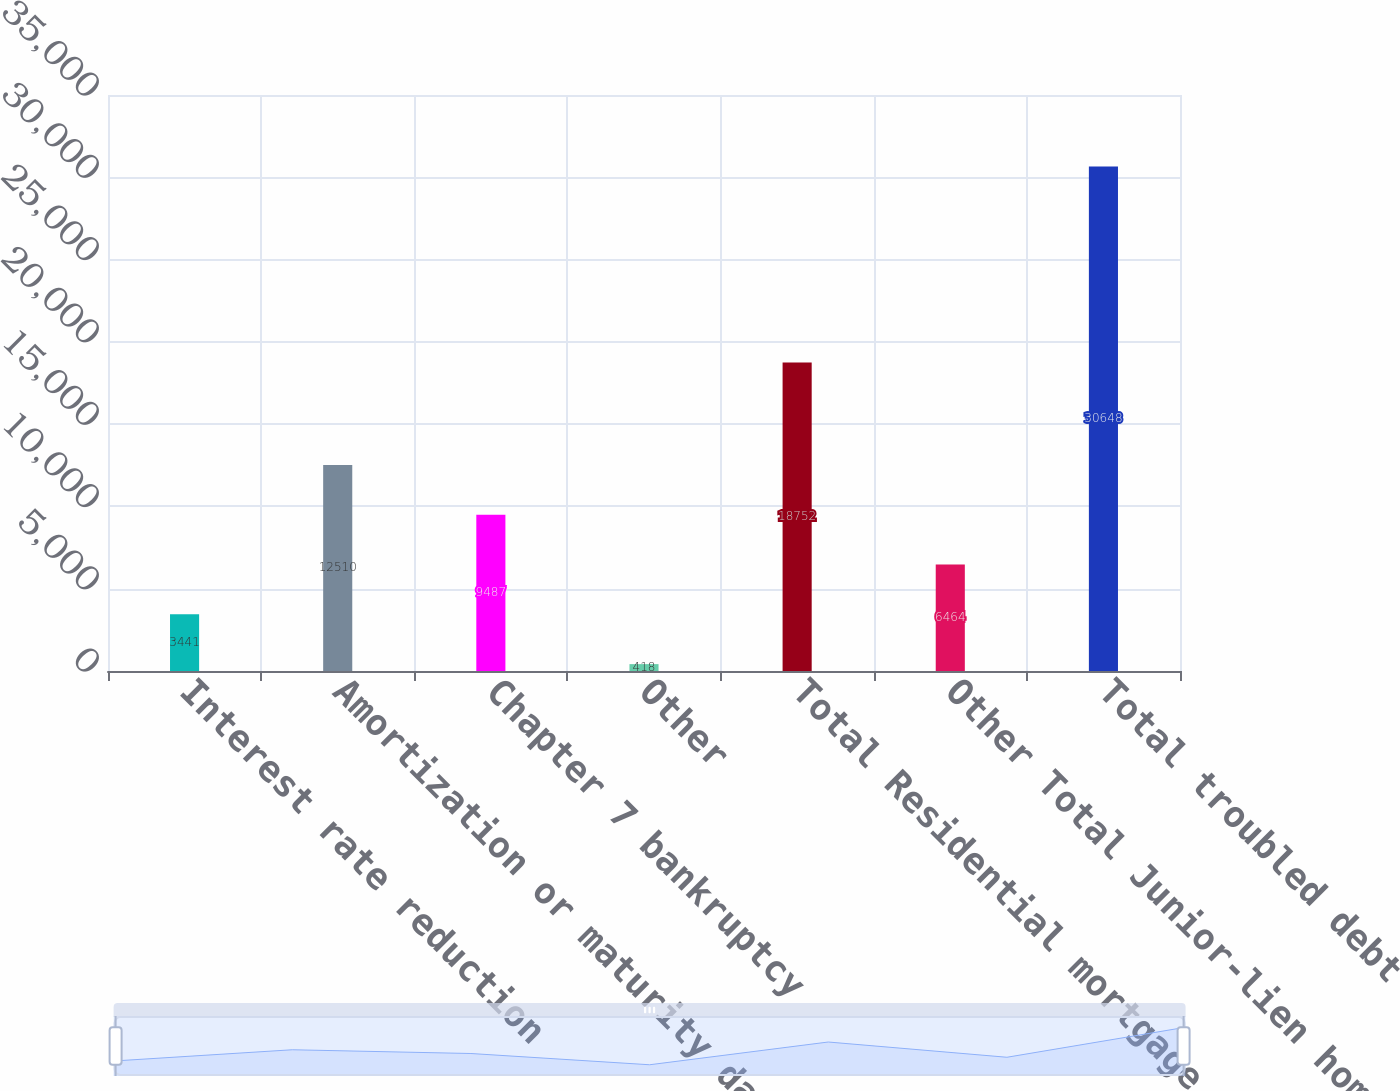<chart> <loc_0><loc_0><loc_500><loc_500><bar_chart><fcel>Interest rate reduction<fcel>Amortization or maturity date<fcel>Chapter 7 bankruptcy<fcel>Other<fcel>Total Residential mortgage<fcel>Other Total Junior-lien home<fcel>Total troubled debt<nl><fcel>3441<fcel>12510<fcel>9487<fcel>418<fcel>18752<fcel>6464<fcel>30648<nl></chart> 